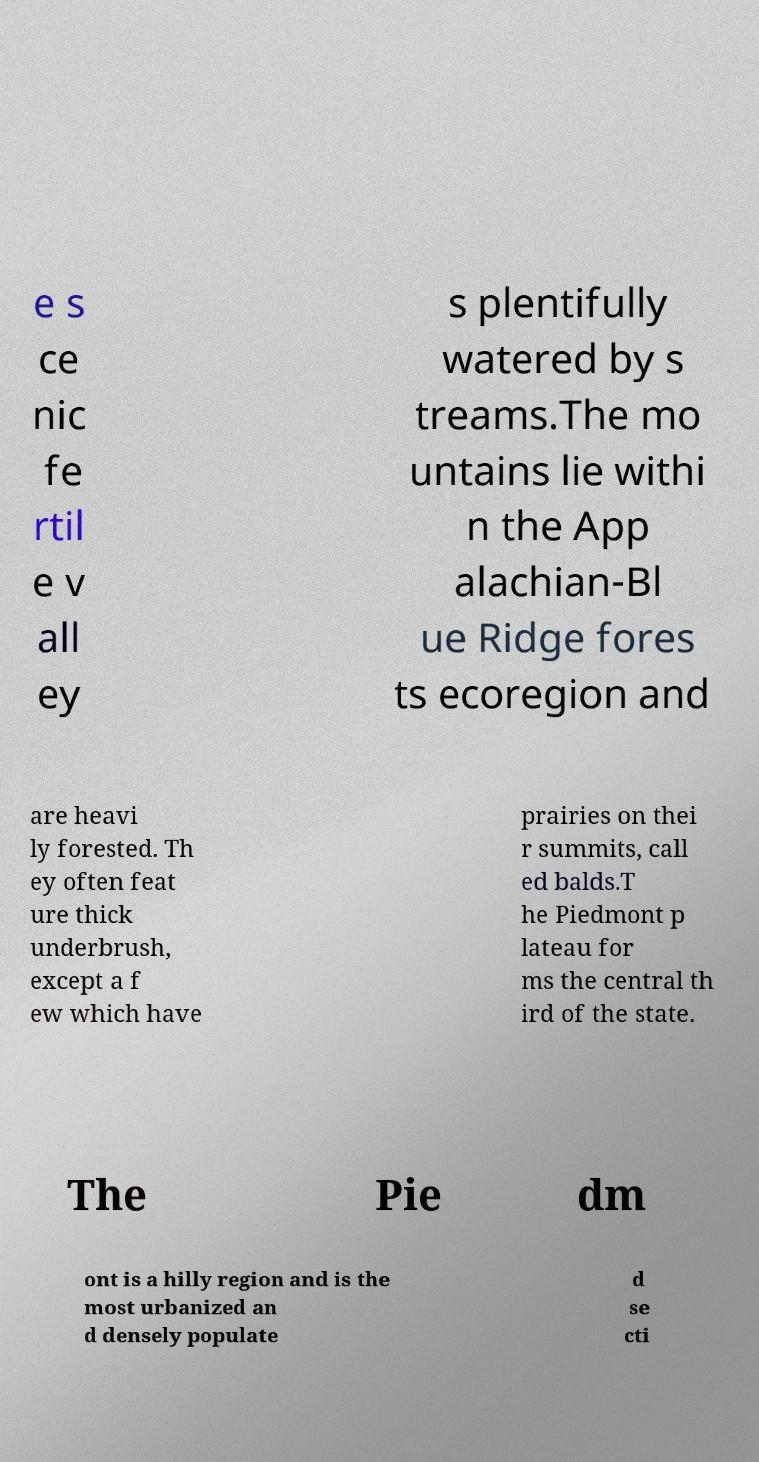What messages or text are displayed in this image? I need them in a readable, typed format. e s ce nic fe rtil e v all ey s plentifully watered by s treams.The mo untains lie withi n the App alachian-Bl ue Ridge fores ts ecoregion and are heavi ly forested. Th ey often feat ure thick underbrush, except a f ew which have prairies on thei r summits, call ed balds.T he Piedmont p lateau for ms the central th ird of the state. The Pie dm ont is a hilly region and is the most urbanized an d densely populate d se cti 